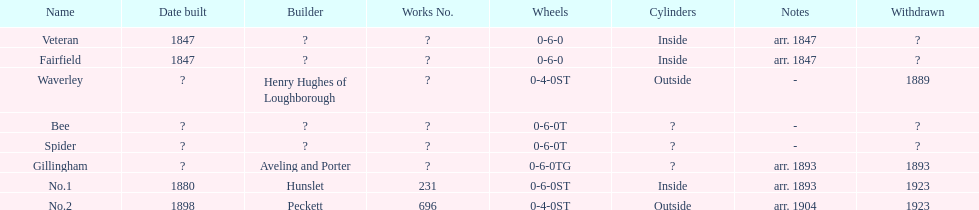Were there more with interior or exterior cylinders? Inside. 